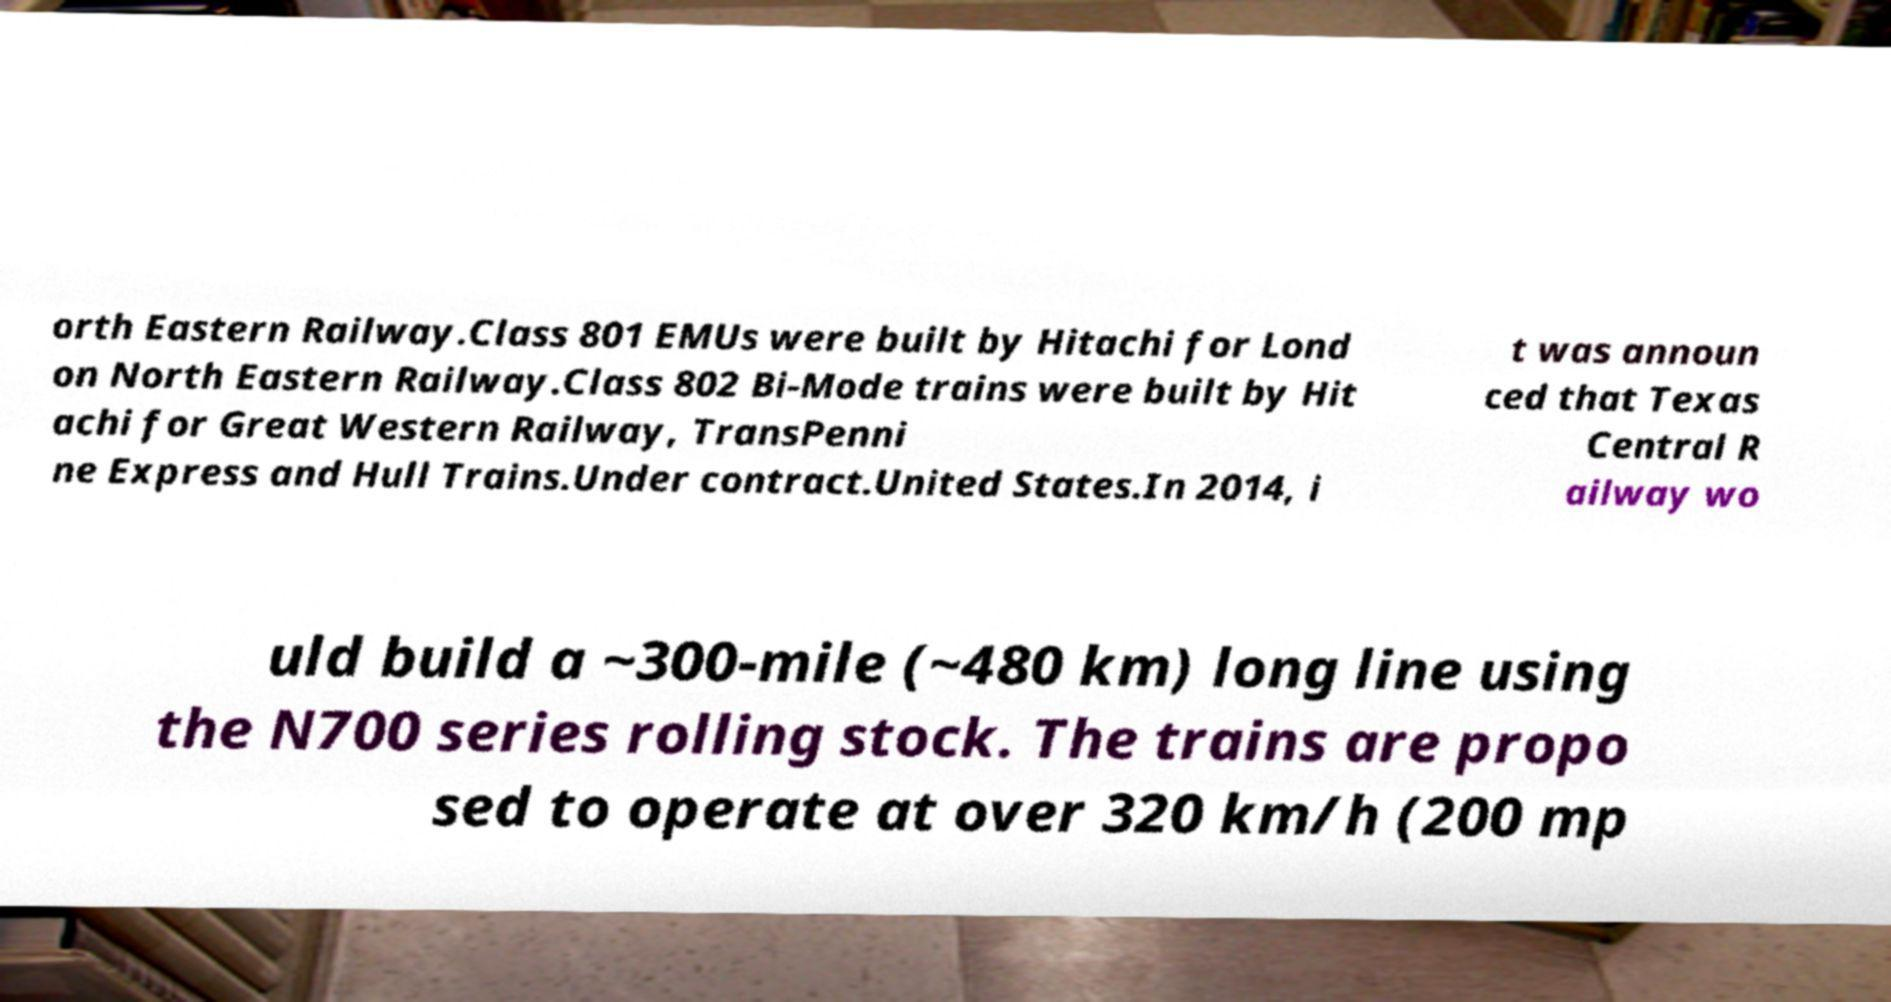Can you read and provide the text displayed in the image?This photo seems to have some interesting text. Can you extract and type it out for me? orth Eastern Railway.Class 801 EMUs were built by Hitachi for Lond on North Eastern Railway.Class 802 Bi-Mode trains were built by Hit achi for Great Western Railway, TransPenni ne Express and Hull Trains.Under contract.United States.In 2014, i t was announ ced that Texas Central R ailway wo uld build a ~300-mile (~480 km) long line using the N700 series rolling stock. The trains are propo sed to operate at over 320 km/h (200 mp 